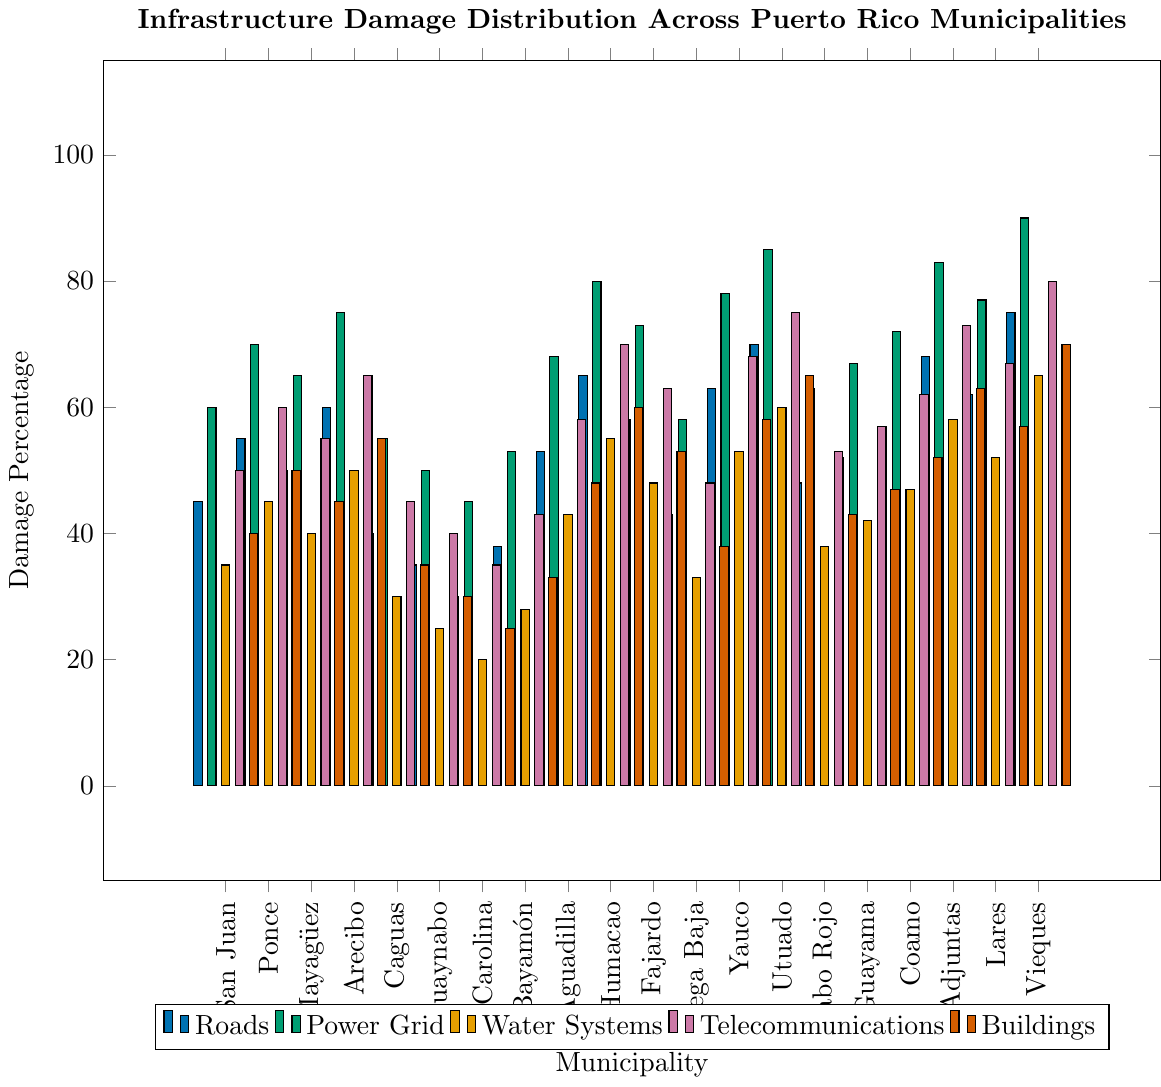What municipality has the highest percentage of road damage? By looking at the blue bars representing road damage, the tallest one belongs to Vieques at 75%.
Answer: Vieques Which municipality has the lowest percentage of power grid damage? The lowest green bar represents power grid damage, and the shortest is Carolina at 45%.
Answer: Carolina What's the average percentage of telecommunications damage for San Juan, Ponce, and Mayagüez? Add the percentages of telecommunications damage for San Juan (50%), Ponce (60%), and Mayagüez (55%), then divide by 3: (50 + 60 + 55) / 3 = 165 / 3 = 55.
Answer: 55 Which two municipalities have equal percentages of water system damage? By comparing the orange bars illustrating water systems damage, both Lares and Coamo have equal percentages of 52%.
Answer: Lares, Coamo Which municipality has the widest range of infrastructure damage percentages? Calculate the range (max - min) for each municipality. Vieques has the widest range: 90% (power grid) - 65% (water systems) = 25%.
Answer: Vieques Compare the percentage of road damage and building damage for Humacao. Which one is higher? For Humacao, the blue bar (road damage) is 65% and the red bar (building damage) is 60%. The road damage percentage is higher.
Answer: Road damage What is the total percentage of infrastructure damage for Utuado when all types are combined? Add the percentages of all types of infrastructure damage for Utuado: 70% (roads) + 85% (power grid) + 60% (water systems) + 75% (telecommunications) + 65% (buildings) = 355%.
Answer: 355 How many municipalities have a higher percentage of telecommunications damage than power grid damage? Compare the purple (telecommunications) and green (power grid) bars. None of the municipalities have telecommunications damage percentages higher than power grid damage.
Answer: 0 Which has more building damage: San Juan or Guayama? Compare the red bars for buildings: San Juan is at 40%, Guayama is at 47%.
Answer: Guayama Which municipality shows the most equal distribution of damage percentages across all types of infrastructure? Check all bar heights for uniformity. Carolina shows the most equal distribution, with the percentages being 30%, 45%, 20%, 35%, and 25%.
Answer: Carolina 